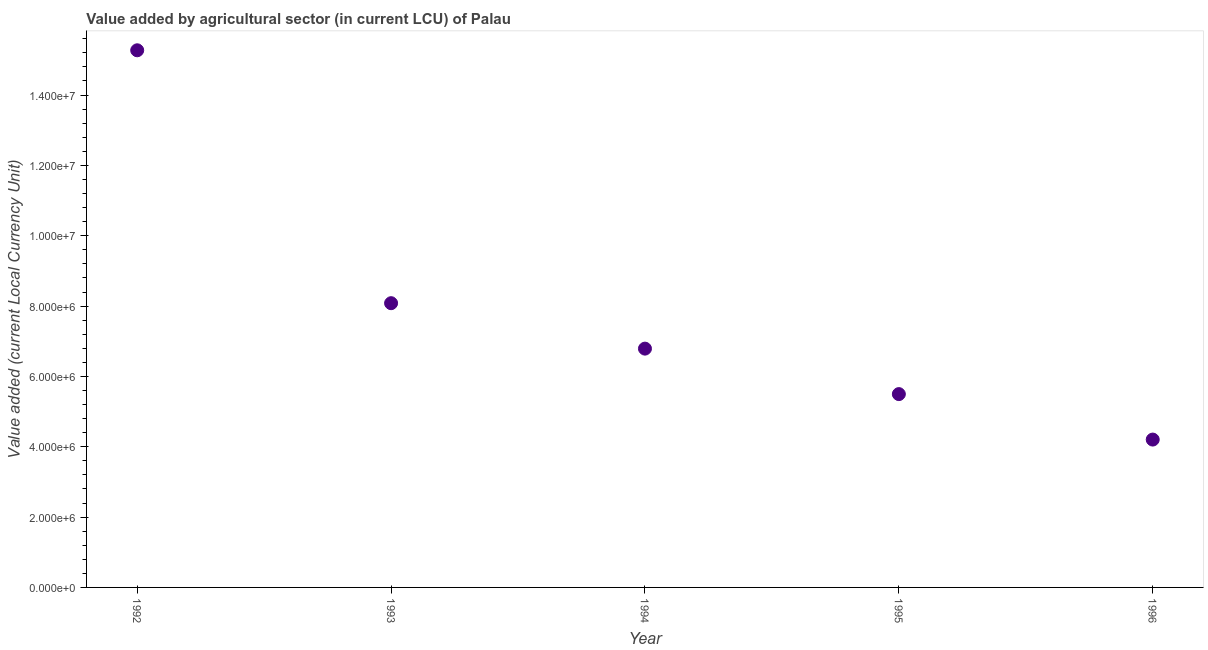What is the value added by agriculture sector in 1996?
Your response must be concise. 4.20e+06. Across all years, what is the maximum value added by agriculture sector?
Provide a succinct answer. 1.53e+07. Across all years, what is the minimum value added by agriculture sector?
Make the answer very short. 4.20e+06. In which year was the value added by agriculture sector minimum?
Give a very brief answer. 1996. What is the sum of the value added by agriculture sector?
Ensure brevity in your answer.  3.98e+07. What is the difference between the value added by agriculture sector in 1992 and 1993?
Make the answer very short. 7.19e+06. What is the average value added by agriculture sector per year?
Provide a short and direct response. 7.97e+06. What is the median value added by agriculture sector?
Provide a succinct answer. 6.79e+06. What is the ratio of the value added by agriculture sector in 1994 to that in 1996?
Offer a terse response. 1.62. Is the difference between the value added by agriculture sector in 1994 and 1996 greater than the difference between any two years?
Offer a terse response. No. What is the difference between the highest and the second highest value added by agriculture sector?
Your answer should be compact. 7.19e+06. What is the difference between the highest and the lowest value added by agriculture sector?
Your answer should be very brief. 1.11e+07. How many years are there in the graph?
Your answer should be very brief. 5. Are the values on the major ticks of Y-axis written in scientific E-notation?
Offer a terse response. Yes. Does the graph contain any zero values?
Your answer should be compact. No. What is the title of the graph?
Offer a terse response. Value added by agricultural sector (in current LCU) of Palau. What is the label or title of the Y-axis?
Provide a short and direct response. Value added (current Local Currency Unit). What is the Value added (current Local Currency Unit) in 1992?
Provide a succinct answer. 1.53e+07. What is the Value added (current Local Currency Unit) in 1993?
Your answer should be very brief. 8.08e+06. What is the Value added (current Local Currency Unit) in 1994?
Your answer should be very brief. 6.79e+06. What is the Value added (current Local Currency Unit) in 1995?
Offer a terse response. 5.50e+06. What is the Value added (current Local Currency Unit) in 1996?
Ensure brevity in your answer.  4.20e+06. What is the difference between the Value added (current Local Currency Unit) in 1992 and 1993?
Your answer should be compact. 7.19e+06. What is the difference between the Value added (current Local Currency Unit) in 1992 and 1994?
Provide a succinct answer. 8.48e+06. What is the difference between the Value added (current Local Currency Unit) in 1992 and 1995?
Make the answer very short. 9.78e+06. What is the difference between the Value added (current Local Currency Unit) in 1992 and 1996?
Make the answer very short. 1.11e+07. What is the difference between the Value added (current Local Currency Unit) in 1993 and 1994?
Your answer should be very brief. 1.29e+06. What is the difference between the Value added (current Local Currency Unit) in 1993 and 1995?
Give a very brief answer. 2.58e+06. What is the difference between the Value added (current Local Currency Unit) in 1993 and 1996?
Your response must be concise. 3.88e+06. What is the difference between the Value added (current Local Currency Unit) in 1994 and 1995?
Keep it short and to the point. 1.29e+06. What is the difference between the Value added (current Local Currency Unit) in 1994 and 1996?
Ensure brevity in your answer.  2.59e+06. What is the difference between the Value added (current Local Currency Unit) in 1995 and 1996?
Your response must be concise. 1.29e+06. What is the ratio of the Value added (current Local Currency Unit) in 1992 to that in 1993?
Ensure brevity in your answer.  1.89. What is the ratio of the Value added (current Local Currency Unit) in 1992 to that in 1994?
Offer a terse response. 2.25. What is the ratio of the Value added (current Local Currency Unit) in 1992 to that in 1995?
Give a very brief answer. 2.78. What is the ratio of the Value added (current Local Currency Unit) in 1992 to that in 1996?
Offer a terse response. 3.63. What is the ratio of the Value added (current Local Currency Unit) in 1993 to that in 1994?
Provide a short and direct response. 1.19. What is the ratio of the Value added (current Local Currency Unit) in 1993 to that in 1995?
Your answer should be compact. 1.47. What is the ratio of the Value added (current Local Currency Unit) in 1993 to that in 1996?
Make the answer very short. 1.92. What is the ratio of the Value added (current Local Currency Unit) in 1994 to that in 1995?
Offer a very short reply. 1.24. What is the ratio of the Value added (current Local Currency Unit) in 1994 to that in 1996?
Your answer should be very brief. 1.61. What is the ratio of the Value added (current Local Currency Unit) in 1995 to that in 1996?
Offer a terse response. 1.31. 